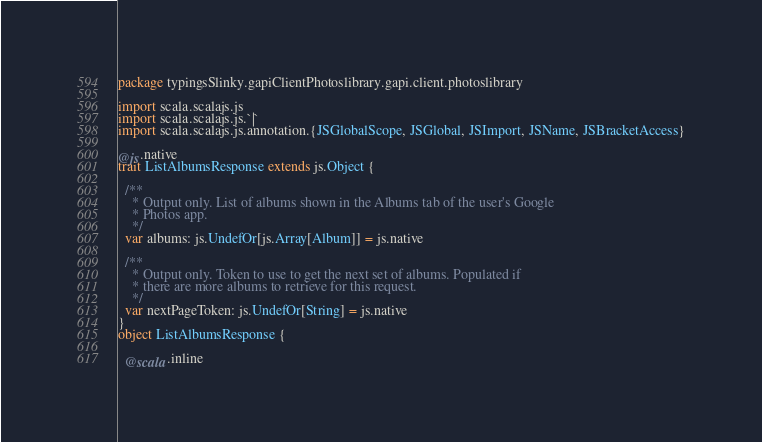<code> <loc_0><loc_0><loc_500><loc_500><_Scala_>package typingsSlinky.gapiClientPhotoslibrary.gapi.client.photoslibrary

import scala.scalajs.js
import scala.scalajs.js.`|`
import scala.scalajs.js.annotation.{JSGlobalScope, JSGlobal, JSImport, JSName, JSBracketAccess}

@js.native
trait ListAlbumsResponse extends js.Object {
  
  /**
    * Output only. List of albums shown in the Albums tab of the user's Google
    * Photos app.
    */
  var albums: js.UndefOr[js.Array[Album]] = js.native
  
  /**
    * Output only. Token to use to get the next set of albums. Populated if
    * there are more albums to retrieve for this request.
    */
  var nextPageToken: js.UndefOr[String] = js.native
}
object ListAlbumsResponse {
  
  @scala.inline</code> 